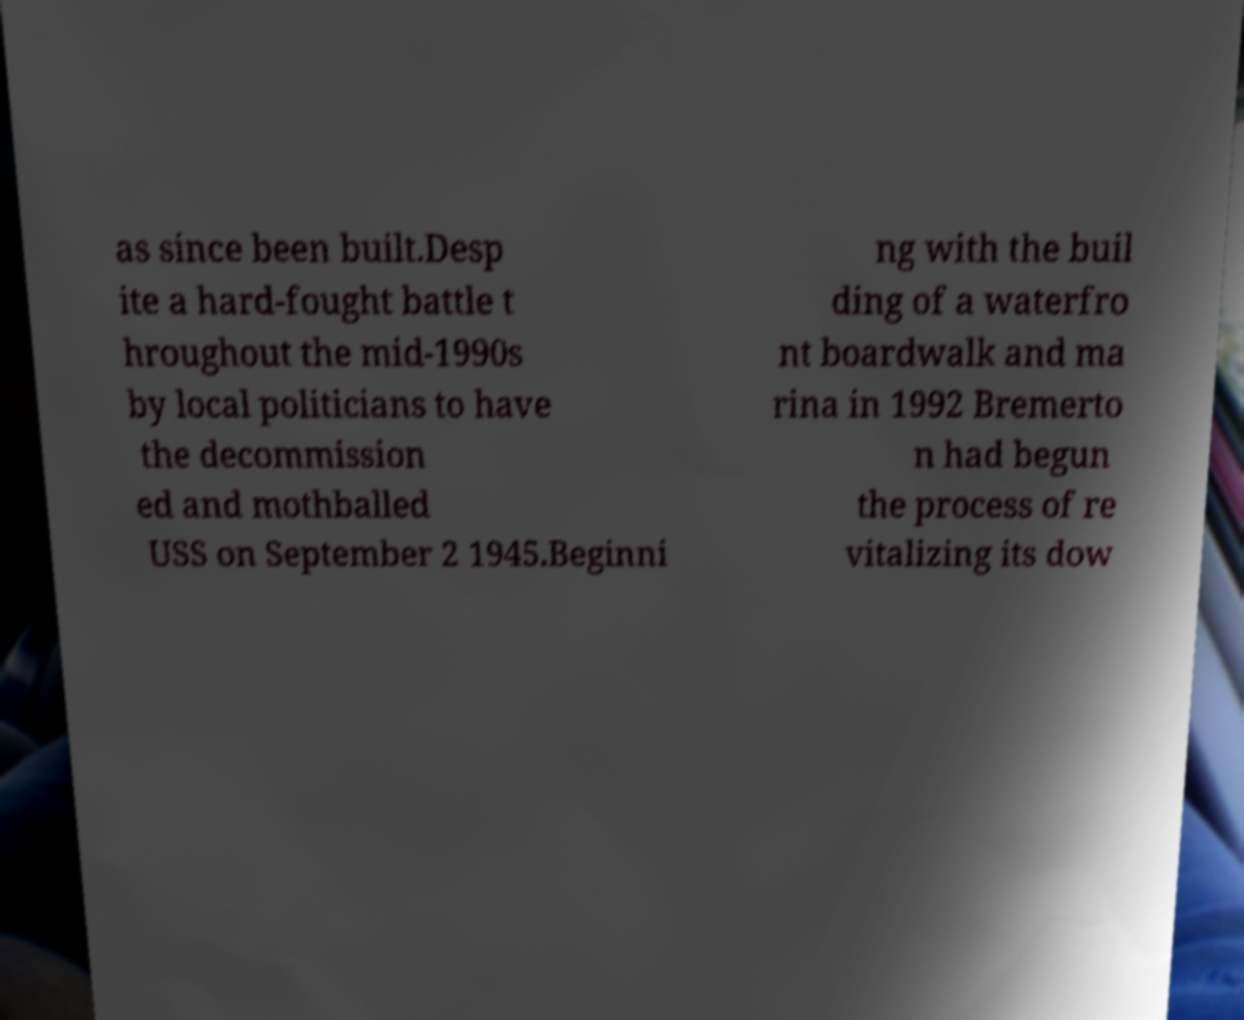Please read and relay the text visible in this image. What does it say? as since been built.Desp ite a hard-fought battle t hroughout the mid-1990s by local politicians to have the decommission ed and mothballed USS on September 2 1945.Beginni ng with the buil ding of a waterfro nt boardwalk and ma rina in 1992 Bremerto n had begun the process of re vitalizing its dow 